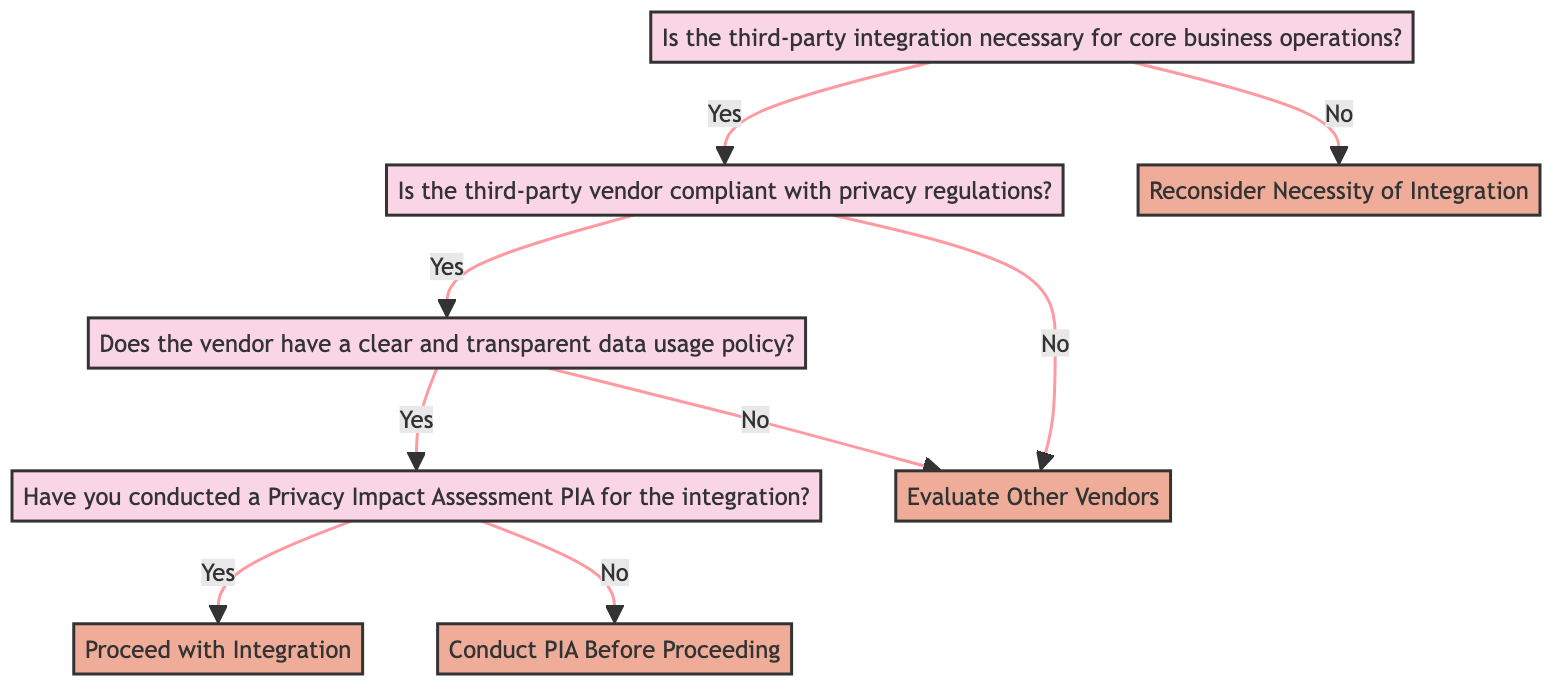Is the first question about the necessity of the third-party integration? The diagram starts with the question "Is the third-party integration necessary for core business operations?" which is positioned at the top as Level 1.
Answer: Yes How many actions are present in the diagram? The diagram includes four actions: "Proceed with Integration," "Conduct PIA Before Proceeding," "Evaluate Other Vendors," and "Reconsider Necessity of Integration." Counting these gives a total of four actions.
Answer: Four What happens if the third-party vendor is not compliant with privacy regulations? If the answer to the question "Is the third-party vendor compliant with privacy regulations?" is "No," the next action specified is "Evaluate Other Vendors."
Answer: Evaluate Other Vendors What is the outcome if the vendor has a clear and transparent data usage policy but no Privacy Impact Assessment is conducted? The diagram shows that if the vendor has a clear data usage policy ("Yes" to the respective question) but the PIA has not been conducted ("No"), the action required is "Conduct PIA Before Proceeding."
Answer: Conduct PIA Before Proceeding Which level focuses on the necessity of the third-party integration? The first decision point in the diagram, which asks about the necessity of the third-party integration, is categorized as Level 1.
Answer: Level 1 If the third-party integration is not necessary, what should be reconsidered according to the diagram? Following a "No" answer to the necessity question, the action states "Reconsider Necessity of Integration," indicating the need to review whether the integration is warranted.
Answer: Reconsider Necessity of Integration What is the second question in the decision tree? The second question, following the first, is "Is the third-party vendor compliant with privacy regulations (e.g., GDPR, CCPA)?" This is indicated as Level 2.
Answer: Is the third-party vendor compliant with privacy regulations? What step follows after confirming the vendor's compliance with privacy regulations? After confirming compliance, the next step is to check if the vendor has a clear and transparent data usage policy, which is the third question in the sequence.
Answer: Check if the vendor has a clear and transparent data usage policy What action is taken if neither the vendor's compliance nor their data policy meets the requirements? If the vendor is not compliant with privacy regulations or does not have a clear data usage policy, the action indicated is to "Evaluate Other Vendors."
Answer: Evaluate Other Vendors 